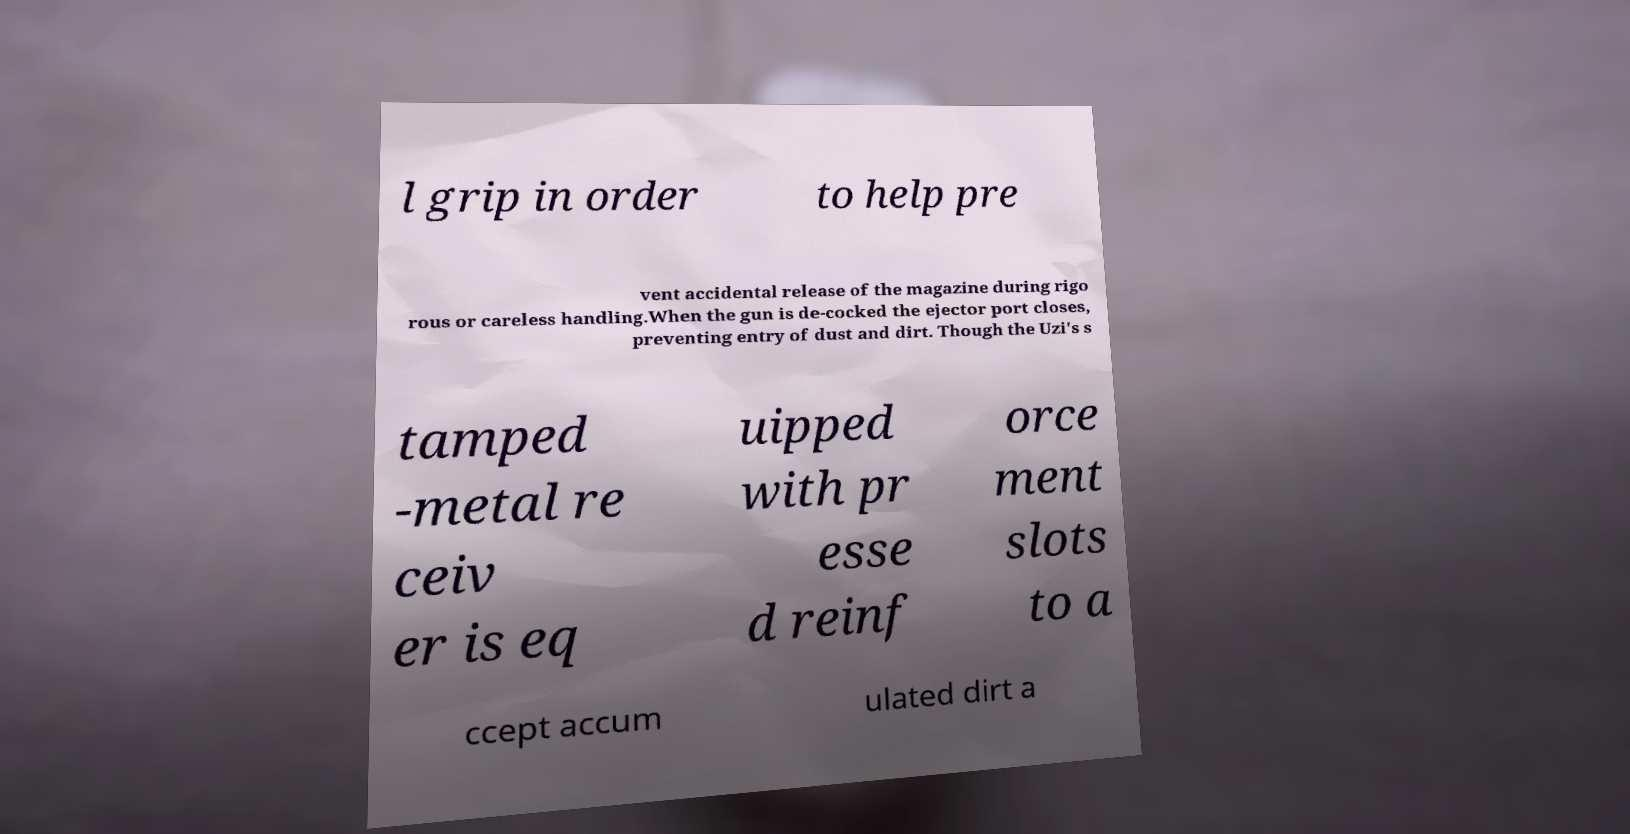For documentation purposes, I need the text within this image transcribed. Could you provide that? l grip in order to help pre vent accidental release of the magazine during rigo rous or careless handling.When the gun is de-cocked the ejector port closes, preventing entry of dust and dirt. Though the Uzi's s tamped -metal re ceiv er is eq uipped with pr esse d reinf orce ment slots to a ccept accum ulated dirt a 